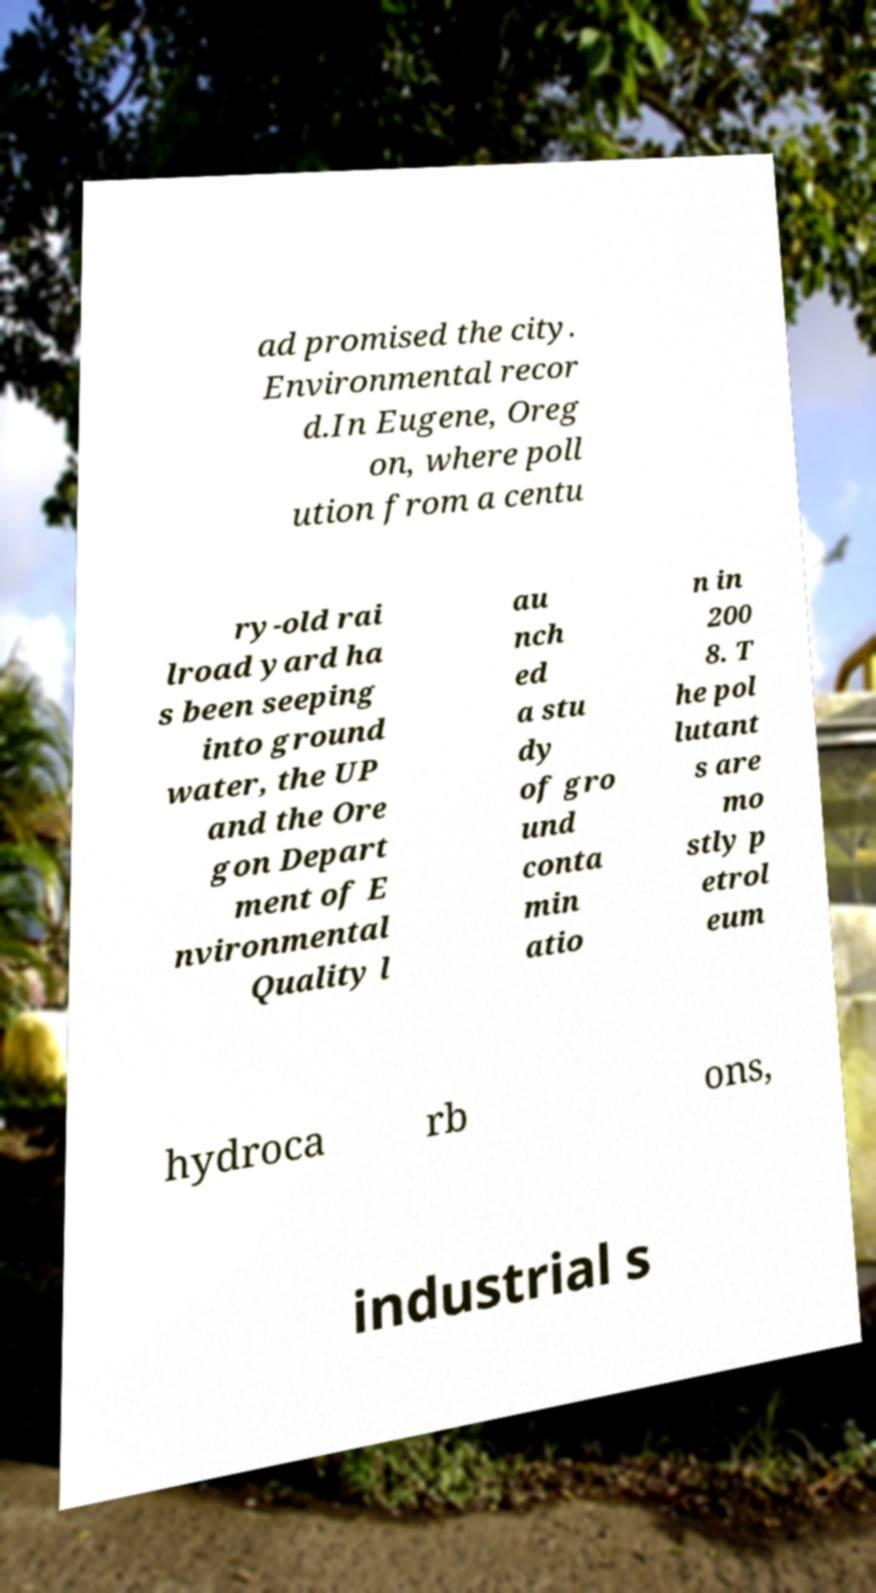There's text embedded in this image that I need extracted. Can you transcribe it verbatim? ad promised the city. Environmental recor d.In Eugene, Oreg on, where poll ution from a centu ry-old rai lroad yard ha s been seeping into ground water, the UP and the Ore gon Depart ment of E nvironmental Quality l au nch ed a stu dy of gro und conta min atio n in 200 8. T he pol lutant s are mo stly p etrol eum hydroca rb ons, industrial s 